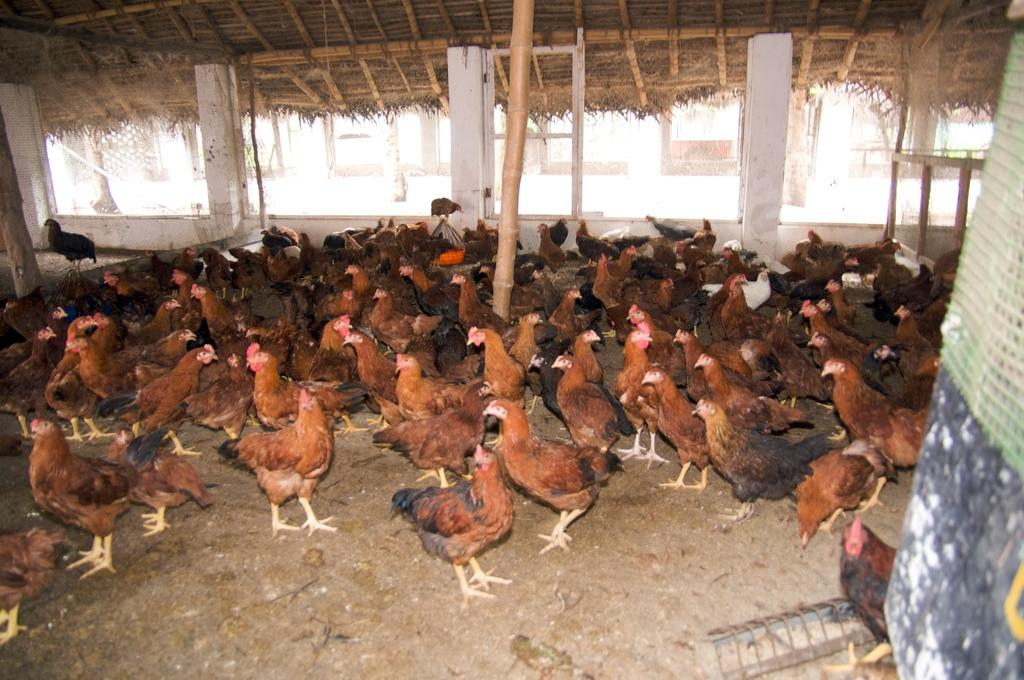What type of animals can be seen on the ground in the image? There are many hens on the ground in the image. Can you describe the background of the image? There is a building visible in the background of the image. What type of fuel is being used by the hens in the image? There is no indication in the image that the hens are using any fuel, as they are not vehicles or machines. 